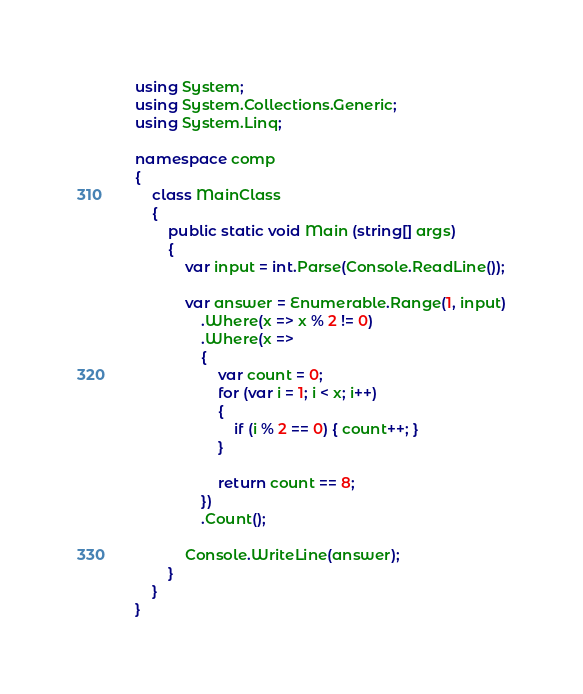Convert code to text. <code><loc_0><loc_0><loc_500><loc_500><_C#_>using System;
using System.Collections.Generic;
using System.Linq;

namespace comp
{
	class MainClass
	{
		public static void Main (string[] args)
		{
			var input = int.Parse(Console.ReadLine());

			var answer = Enumerable.Range(1, input)
				.Where(x => x % 2 != 0)
				.Where(x =>
				{
					var count = 0;
					for (var i = 1; i < x; i++)
					{
						if (i % 2 == 0) { count++; }
					}

					return count == 8;
				})
				.Count();

			Console.WriteLine(answer);
		}
	}
}
</code> 